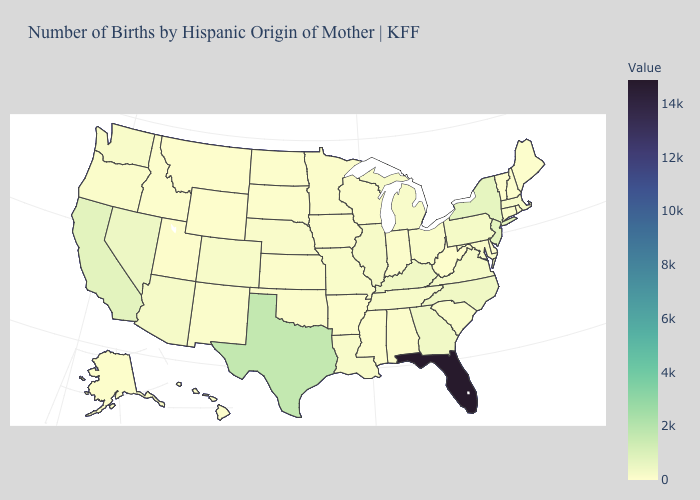Which states have the lowest value in the MidWest?
Be succinct. South Dakota. Among the states that border Maine , which have the highest value?
Quick response, please. New Hampshire. Does the map have missing data?
Concise answer only. No. Does the map have missing data?
Concise answer only. No. Among the states that border Delaware , does Pennsylvania have the lowest value?
Be succinct. No. Which states have the highest value in the USA?
Quick response, please. Florida. 